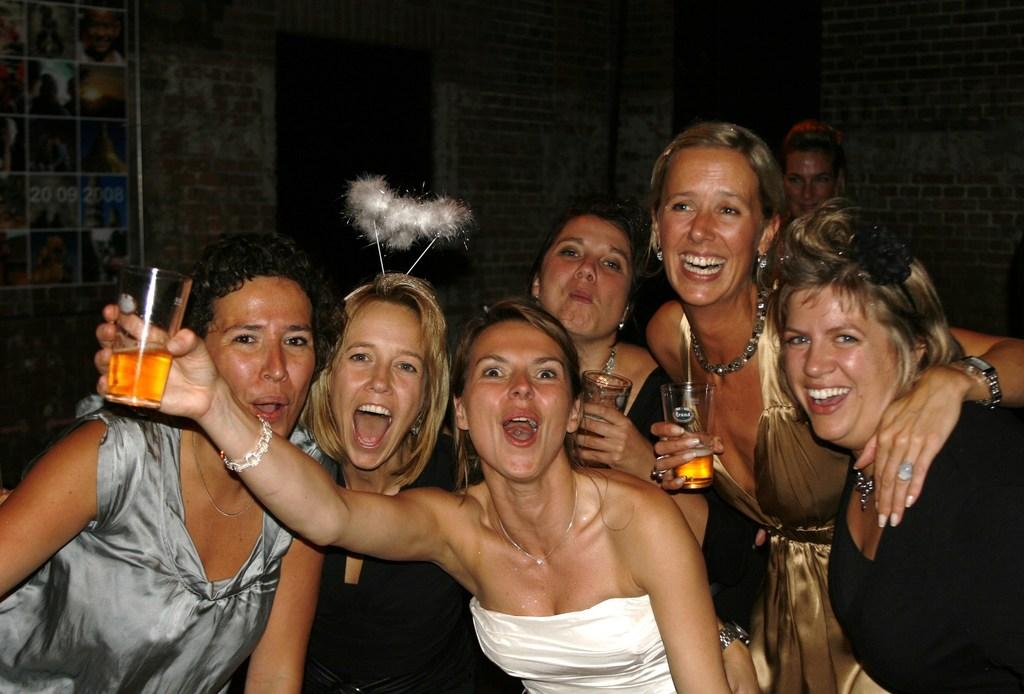What are the ladies in the image doing? The ladies are standing in the image and holding glasses. What can be seen in the background of the image? There is a wall in the background of the image. Is there anything placed on the wall in the background? Yes, there is a poster placed on the wall in the background. What type of system is being discussed in the meeting in the image? There is no meeting present in the image, so it is not possible to determine what type of system might be discussed. Can you tell me how many cherries are on the poster in the image? There are no cherries present in the image, as the poster features something else. 